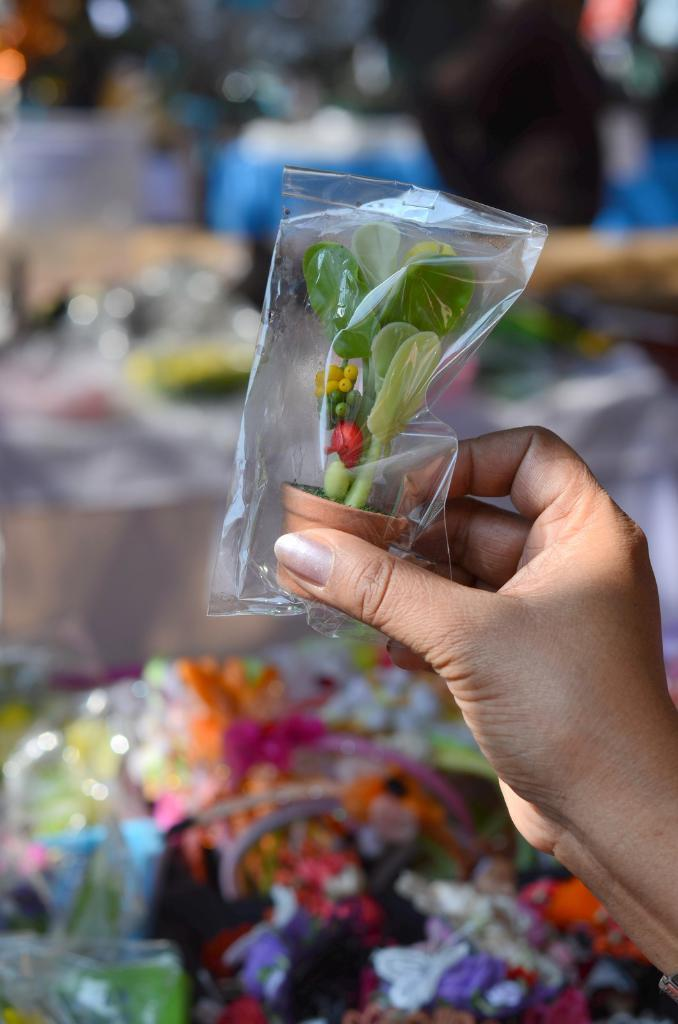What is the person holding in the image? The person is holding a packet in the image. What can be found inside the packet? Inside the packet, there is a toy pot with a plant. Can you describe the background of the image? The background of the image contains a few objects, but they are blurry. How does the person in the image promote peace with their hand gesture? There is no hand gesture present in the image that promotes peace. The person is simply holding a packet. 